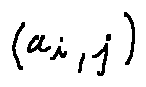Convert formula to latex. <formula><loc_0><loc_0><loc_500><loc_500>( a _ { i , j } )</formula> 